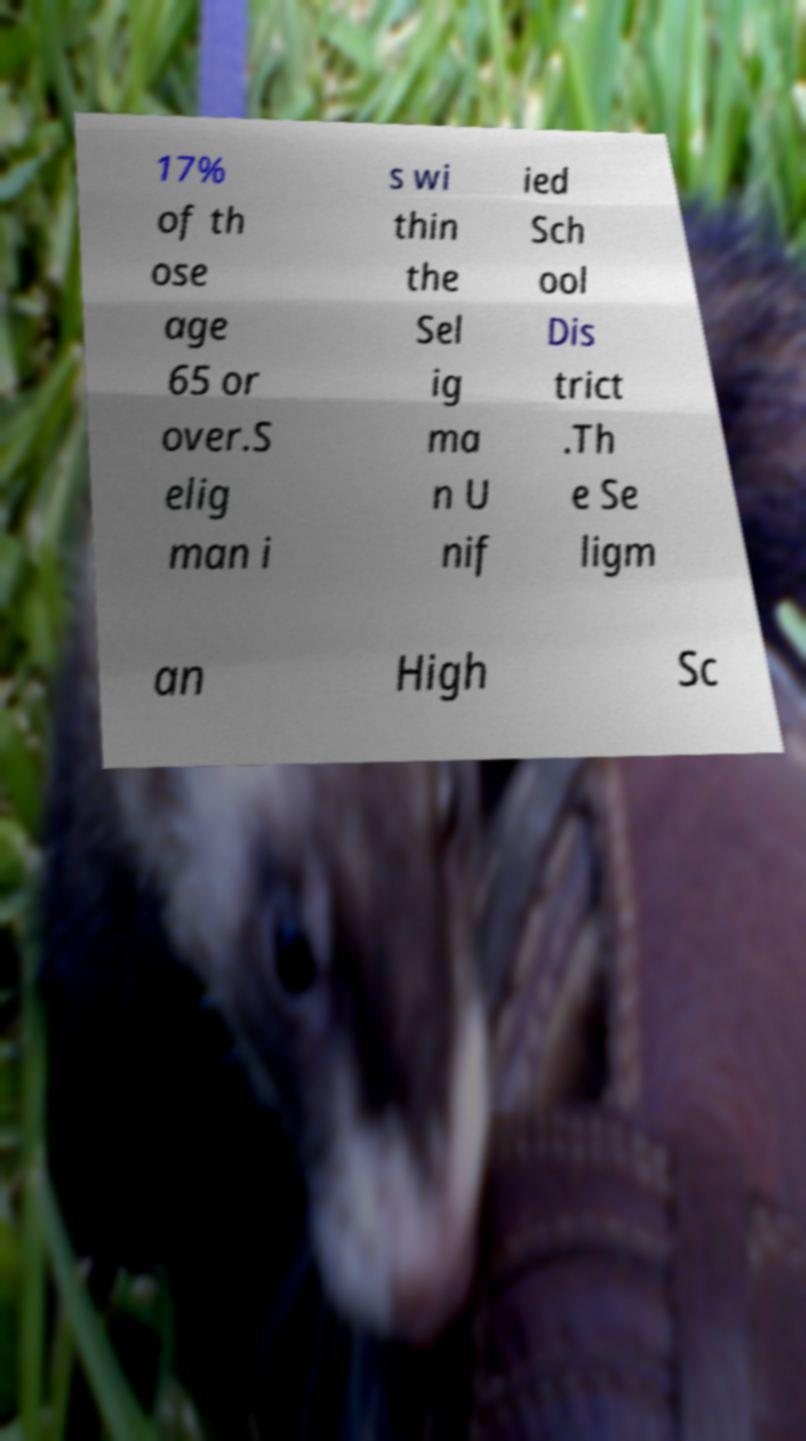I need the written content from this picture converted into text. Can you do that? 17% of th ose age 65 or over.S elig man i s wi thin the Sel ig ma n U nif ied Sch ool Dis trict .Th e Se ligm an High Sc 